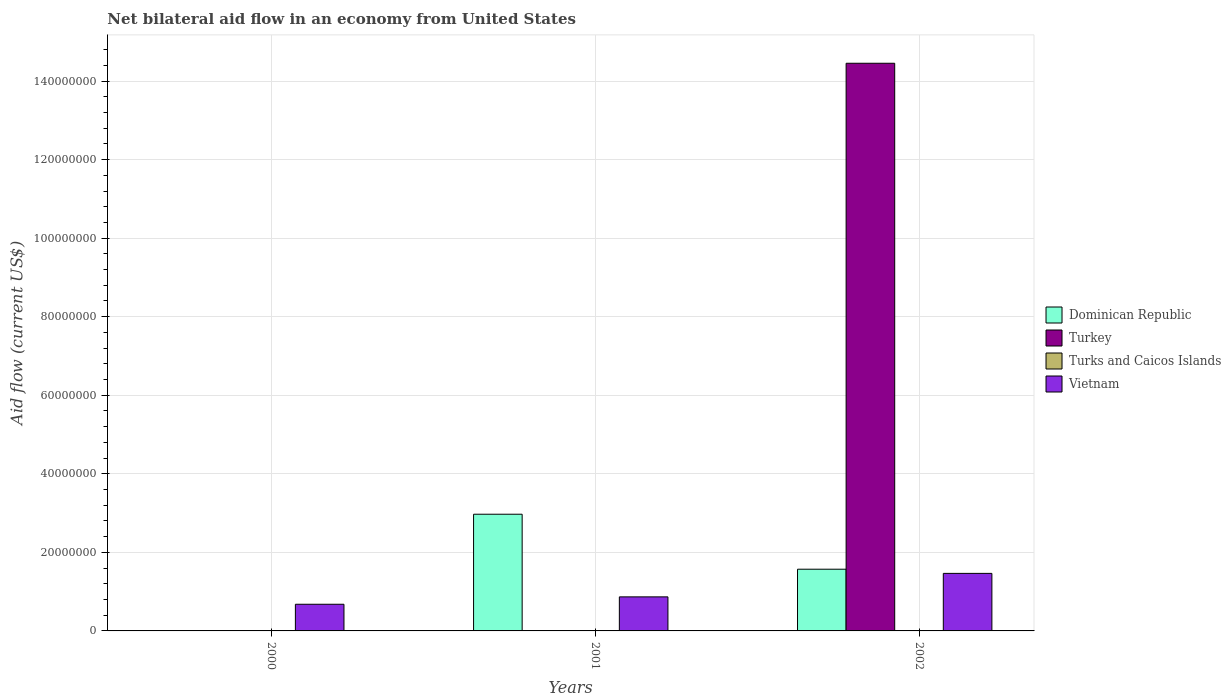How many different coloured bars are there?
Provide a succinct answer. 4. Are the number of bars on each tick of the X-axis equal?
Your answer should be compact. No. How many bars are there on the 2nd tick from the left?
Make the answer very short. 3. What is the label of the 1st group of bars from the left?
Make the answer very short. 2000. Across all years, what is the maximum net bilateral aid flow in Vietnam?
Your answer should be very brief. 1.46e+07. Across all years, what is the minimum net bilateral aid flow in Turks and Caicos Islands?
Keep it short and to the point. 10000. What is the total net bilateral aid flow in Dominican Republic in the graph?
Offer a very short reply. 4.54e+07. What is the difference between the net bilateral aid flow in Turks and Caicos Islands in 2000 and that in 2002?
Give a very brief answer. 0. What is the difference between the net bilateral aid flow in Turkey in 2000 and the net bilateral aid flow in Vietnam in 2001?
Your response must be concise. -8.67e+06. What is the average net bilateral aid flow in Dominican Republic per year?
Your response must be concise. 1.51e+07. In the year 2001, what is the difference between the net bilateral aid flow in Turks and Caicos Islands and net bilateral aid flow in Vietnam?
Your answer should be compact. -8.63e+06. Is the net bilateral aid flow in Vietnam in 2000 less than that in 2001?
Your answer should be compact. Yes. What is the difference between the highest and the second highest net bilateral aid flow in Vietnam?
Give a very brief answer. 5.98e+06. What is the difference between the highest and the lowest net bilateral aid flow in Turkey?
Ensure brevity in your answer.  1.45e+08. How many bars are there?
Make the answer very short. 9. Are all the bars in the graph horizontal?
Make the answer very short. No. Are the values on the major ticks of Y-axis written in scientific E-notation?
Offer a terse response. No. Does the graph contain any zero values?
Offer a terse response. Yes. What is the title of the graph?
Keep it short and to the point. Net bilateral aid flow in an economy from United States. What is the label or title of the X-axis?
Keep it short and to the point. Years. What is the label or title of the Y-axis?
Make the answer very short. Aid flow (current US$). What is the Aid flow (current US$) in Turkey in 2000?
Ensure brevity in your answer.  0. What is the Aid flow (current US$) in Vietnam in 2000?
Provide a short and direct response. 6.79e+06. What is the Aid flow (current US$) in Dominican Republic in 2001?
Offer a terse response. 2.97e+07. What is the Aid flow (current US$) in Vietnam in 2001?
Your answer should be very brief. 8.67e+06. What is the Aid flow (current US$) in Dominican Republic in 2002?
Give a very brief answer. 1.57e+07. What is the Aid flow (current US$) of Turkey in 2002?
Make the answer very short. 1.45e+08. What is the Aid flow (current US$) in Vietnam in 2002?
Give a very brief answer. 1.46e+07. Across all years, what is the maximum Aid flow (current US$) of Dominican Republic?
Your answer should be compact. 2.97e+07. Across all years, what is the maximum Aid flow (current US$) in Turkey?
Give a very brief answer. 1.45e+08. Across all years, what is the maximum Aid flow (current US$) in Turks and Caicos Islands?
Provide a succinct answer. 4.00e+04. Across all years, what is the maximum Aid flow (current US$) of Vietnam?
Your answer should be very brief. 1.46e+07. Across all years, what is the minimum Aid flow (current US$) in Dominican Republic?
Provide a short and direct response. 0. Across all years, what is the minimum Aid flow (current US$) of Turkey?
Your response must be concise. 0. Across all years, what is the minimum Aid flow (current US$) in Turks and Caicos Islands?
Your answer should be compact. 10000. Across all years, what is the minimum Aid flow (current US$) in Vietnam?
Your answer should be very brief. 6.79e+06. What is the total Aid flow (current US$) in Dominican Republic in the graph?
Provide a succinct answer. 4.54e+07. What is the total Aid flow (current US$) of Turkey in the graph?
Your response must be concise. 1.45e+08. What is the total Aid flow (current US$) of Vietnam in the graph?
Offer a terse response. 3.01e+07. What is the difference between the Aid flow (current US$) of Turks and Caicos Islands in 2000 and that in 2001?
Make the answer very short. -3.00e+04. What is the difference between the Aid flow (current US$) of Vietnam in 2000 and that in 2001?
Your answer should be very brief. -1.88e+06. What is the difference between the Aid flow (current US$) of Turks and Caicos Islands in 2000 and that in 2002?
Keep it short and to the point. 0. What is the difference between the Aid flow (current US$) of Vietnam in 2000 and that in 2002?
Give a very brief answer. -7.86e+06. What is the difference between the Aid flow (current US$) of Dominican Republic in 2001 and that in 2002?
Provide a short and direct response. 1.40e+07. What is the difference between the Aid flow (current US$) in Vietnam in 2001 and that in 2002?
Provide a short and direct response. -5.98e+06. What is the difference between the Aid flow (current US$) of Turks and Caicos Islands in 2000 and the Aid flow (current US$) of Vietnam in 2001?
Provide a succinct answer. -8.66e+06. What is the difference between the Aid flow (current US$) of Turks and Caicos Islands in 2000 and the Aid flow (current US$) of Vietnam in 2002?
Your response must be concise. -1.46e+07. What is the difference between the Aid flow (current US$) of Dominican Republic in 2001 and the Aid flow (current US$) of Turkey in 2002?
Keep it short and to the point. -1.15e+08. What is the difference between the Aid flow (current US$) of Dominican Republic in 2001 and the Aid flow (current US$) of Turks and Caicos Islands in 2002?
Your answer should be compact. 2.97e+07. What is the difference between the Aid flow (current US$) in Dominican Republic in 2001 and the Aid flow (current US$) in Vietnam in 2002?
Ensure brevity in your answer.  1.51e+07. What is the difference between the Aid flow (current US$) in Turks and Caicos Islands in 2001 and the Aid flow (current US$) in Vietnam in 2002?
Provide a short and direct response. -1.46e+07. What is the average Aid flow (current US$) of Dominican Republic per year?
Offer a very short reply. 1.51e+07. What is the average Aid flow (current US$) of Turkey per year?
Your response must be concise. 4.82e+07. What is the average Aid flow (current US$) in Vietnam per year?
Make the answer very short. 1.00e+07. In the year 2000, what is the difference between the Aid flow (current US$) of Turks and Caicos Islands and Aid flow (current US$) of Vietnam?
Make the answer very short. -6.78e+06. In the year 2001, what is the difference between the Aid flow (current US$) in Dominican Republic and Aid flow (current US$) in Turks and Caicos Islands?
Keep it short and to the point. 2.97e+07. In the year 2001, what is the difference between the Aid flow (current US$) in Dominican Republic and Aid flow (current US$) in Vietnam?
Ensure brevity in your answer.  2.10e+07. In the year 2001, what is the difference between the Aid flow (current US$) of Turks and Caicos Islands and Aid flow (current US$) of Vietnam?
Give a very brief answer. -8.63e+06. In the year 2002, what is the difference between the Aid flow (current US$) in Dominican Republic and Aid flow (current US$) in Turkey?
Offer a very short reply. -1.29e+08. In the year 2002, what is the difference between the Aid flow (current US$) of Dominican Republic and Aid flow (current US$) of Turks and Caicos Islands?
Keep it short and to the point. 1.57e+07. In the year 2002, what is the difference between the Aid flow (current US$) in Dominican Republic and Aid flow (current US$) in Vietnam?
Your answer should be compact. 1.06e+06. In the year 2002, what is the difference between the Aid flow (current US$) in Turkey and Aid flow (current US$) in Turks and Caicos Islands?
Make the answer very short. 1.45e+08. In the year 2002, what is the difference between the Aid flow (current US$) of Turkey and Aid flow (current US$) of Vietnam?
Offer a terse response. 1.30e+08. In the year 2002, what is the difference between the Aid flow (current US$) in Turks and Caicos Islands and Aid flow (current US$) in Vietnam?
Provide a short and direct response. -1.46e+07. What is the ratio of the Aid flow (current US$) in Turks and Caicos Islands in 2000 to that in 2001?
Your response must be concise. 0.25. What is the ratio of the Aid flow (current US$) of Vietnam in 2000 to that in 2001?
Provide a short and direct response. 0.78. What is the ratio of the Aid flow (current US$) of Vietnam in 2000 to that in 2002?
Your answer should be compact. 0.46. What is the ratio of the Aid flow (current US$) in Dominican Republic in 2001 to that in 2002?
Provide a succinct answer. 1.89. What is the ratio of the Aid flow (current US$) of Turks and Caicos Islands in 2001 to that in 2002?
Ensure brevity in your answer.  4. What is the ratio of the Aid flow (current US$) in Vietnam in 2001 to that in 2002?
Make the answer very short. 0.59. What is the difference between the highest and the second highest Aid flow (current US$) of Turks and Caicos Islands?
Make the answer very short. 3.00e+04. What is the difference between the highest and the second highest Aid flow (current US$) of Vietnam?
Your answer should be compact. 5.98e+06. What is the difference between the highest and the lowest Aid flow (current US$) of Dominican Republic?
Provide a succinct answer. 2.97e+07. What is the difference between the highest and the lowest Aid flow (current US$) of Turkey?
Keep it short and to the point. 1.45e+08. What is the difference between the highest and the lowest Aid flow (current US$) in Turks and Caicos Islands?
Make the answer very short. 3.00e+04. What is the difference between the highest and the lowest Aid flow (current US$) in Vietnam?
Offer a terse response. 7.86e+06. 